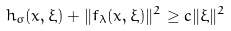<formula> <loc_0><loc_0><loc_500><loc_500>h _ { \sigma } ( x , \xi ) + \| f _ { \lambda } ( x , \xi ) \| ^ { 2 } \geq c \| \xi \| ^ { 2 }</formula> 